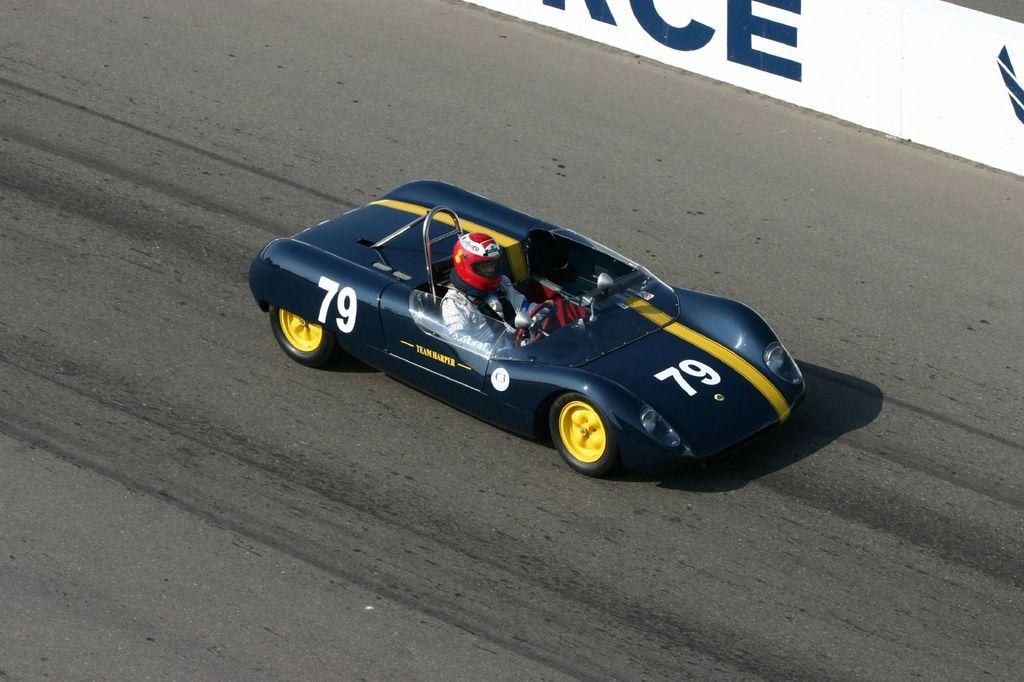What is on the road in the image? There is a vehicle on the road in the image. Who is inside the vehicle? A person is sitting in the vehicle. What can be seen in the background of the image? There is a board visible in the background of the image. What type of chin can be seen on the berry in the image? There is no berry or chin present in the image. How does the society depicted in the image function? There is no society depicted in the image; it only shows a vehicle on the road with a person inside and a board in the background. 